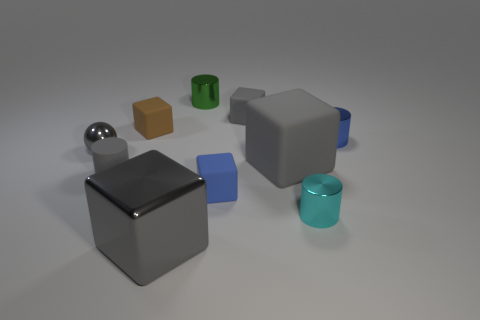There is a rubber cube on the left side of the tiny green cylinder; is it the same size as the gray metal thing that is behind the small rubber cylinder?
Offer a very short reply. Yes. How many objects are either gray metallic objects on the right side of the metallic sphere or tiny gray matte objects right of the small green metallic cylinder?
Ensure brevity in your answer.  2. Is there anything else that has the same shape as the small gray metallic object?
Offer a very short reply. No. Is the color of the small rubber cube in front of the brown rubber block the same as the metallic thing to the right of the small cyan cylinder?
Your answer should be very brief. Yes. What number of metallic things are blue cubes or big blue cubes?
Ensure brevity in your answer.  0. There is a tiny metallic object behind the small blue thing that is to the right of the cyan cylinder; what is its shape?
Your answer should be compact. Cylinder. Are the gray block that is behind the blue metal cylinder and the large gray block behind the small gray matte cylinder made of the same material?
Offer a terse response. Yes. How many big gray things are behind the big gray shiny object that is in front of the small blue rubber thing?
Your response must be concise. 1. There is a gray thing behind the blue metallic object; does it have the same shape as the blue object that is behind the metallic sphere?
Make the answer very short. No. There is a matte thing that is both to the right of the brown rubber object and behind the small blue cylinder; what size is it?
Make the answer very short. Small. 